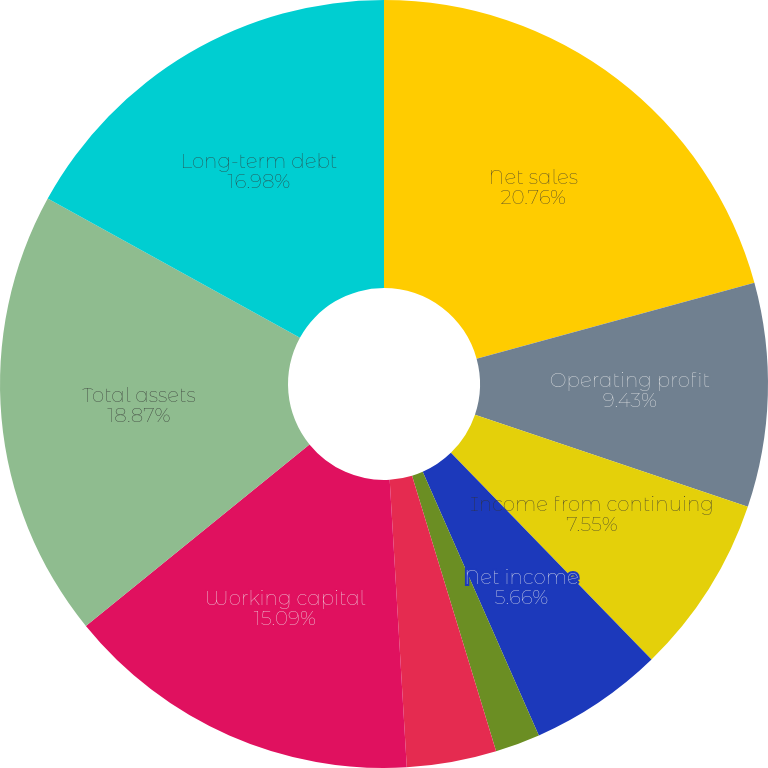Convert chart to OTSL. <chart><loc_0><loc_0><loc_500><loc_500><pie_chart><fcel>Net sales<fcel>Operating profit<fcel>Income from continuing<fcel>Net income<fcel>Continuing operations<fcel>Discontinued operations<fcel>Cash and cash equivalents<fcel>Working capital<fcel>Total assets<fcel>Long-term debt<nl><fcel>20.75%<fcel>9.43%<fcel>7.55%<fcel>5.66%<fcel>1.89%<fcel>0.0%<fcel>3.77%<fcel>15.09%<fcel>18.87%<fcel>16.98%<nl></chart> 